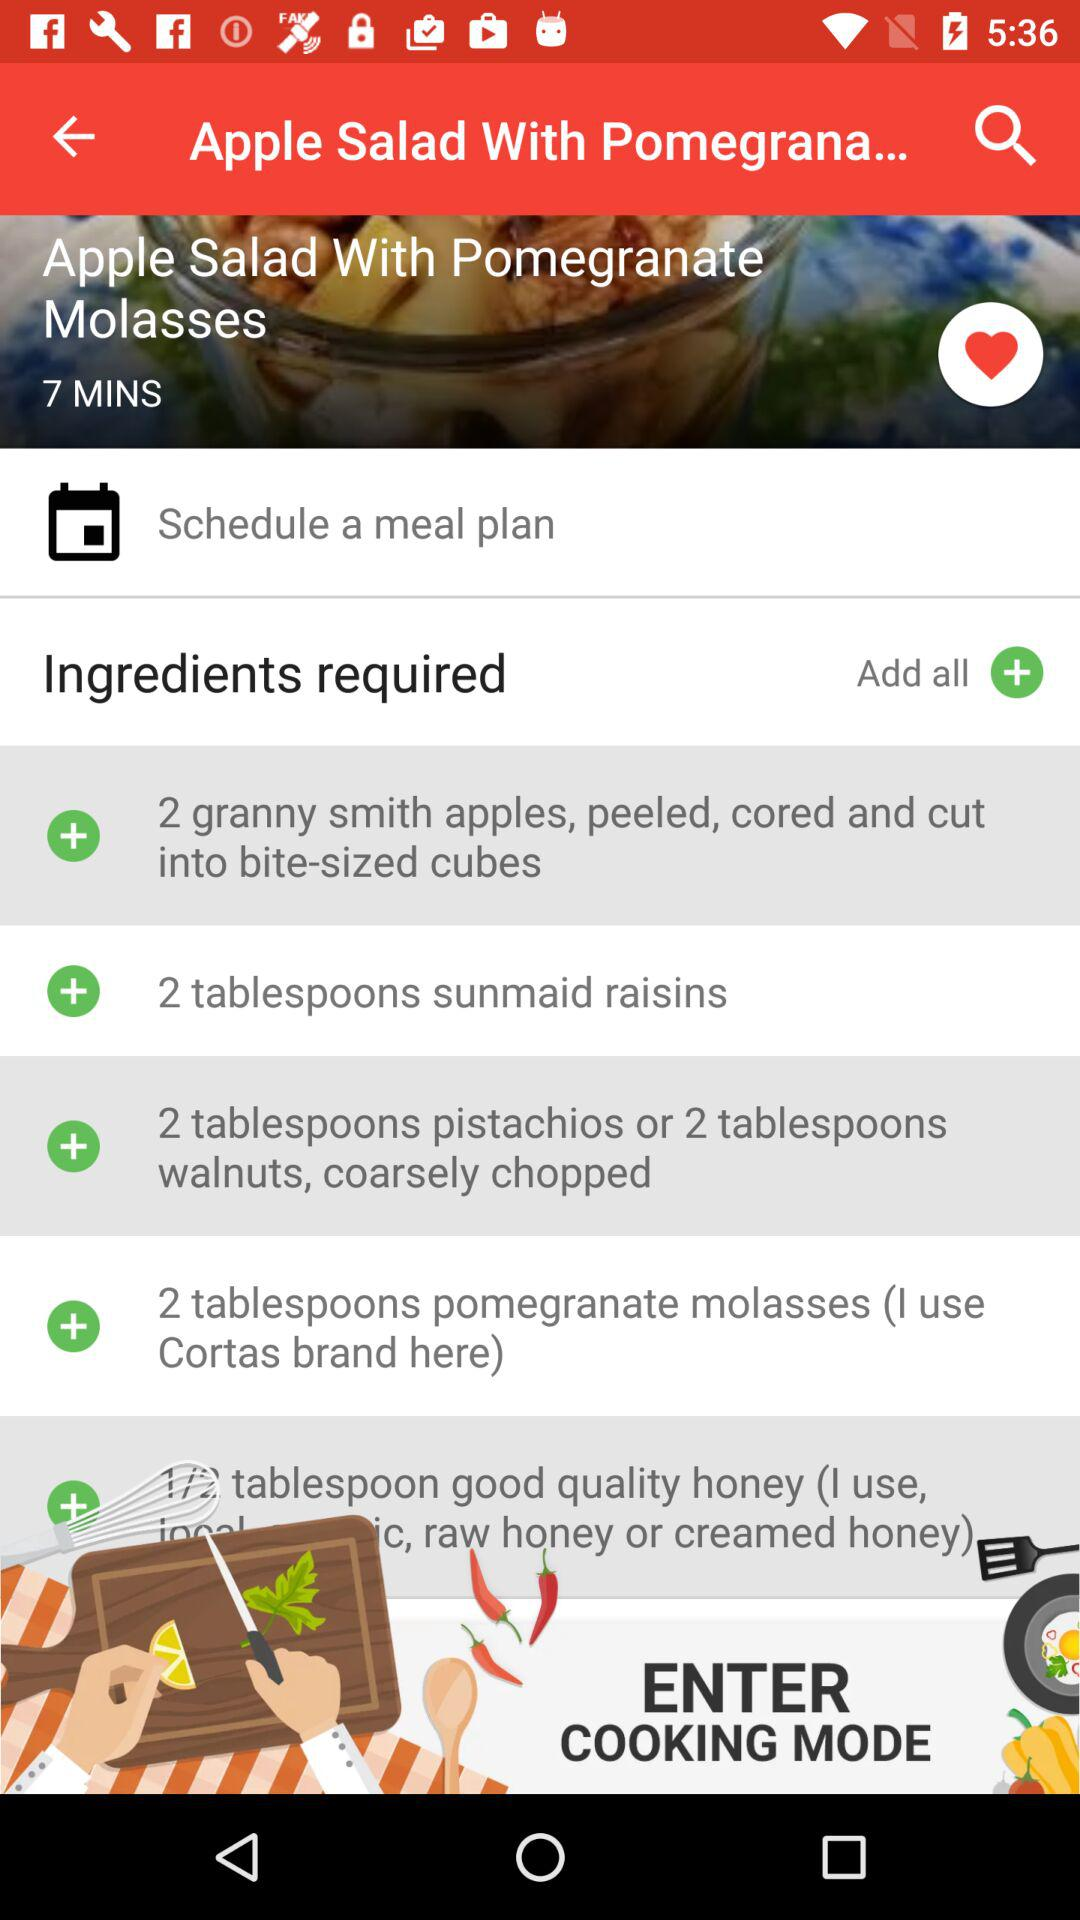How many tablespoons of sunmaid raisins are required to make "Apple Salad With Pomegranate Molasses"? There are 2 tablespoons required. 